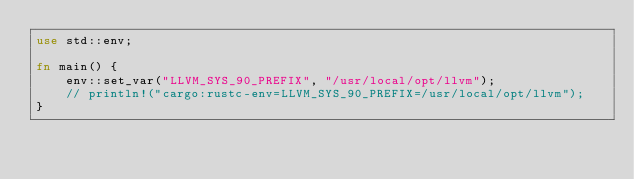<code> <loc_0><loc_0><loc_500><loc_500><_Rust_>use std::env;

fn main() {
    env::set_var("LLVM_SYS_90_PREFIX", "/usr/local/opt/llvm");
    // println!("cargo:rustc-env=LLVM_SYS_90_PREFIX=/usr/local/opt/llvm");
}</code> 